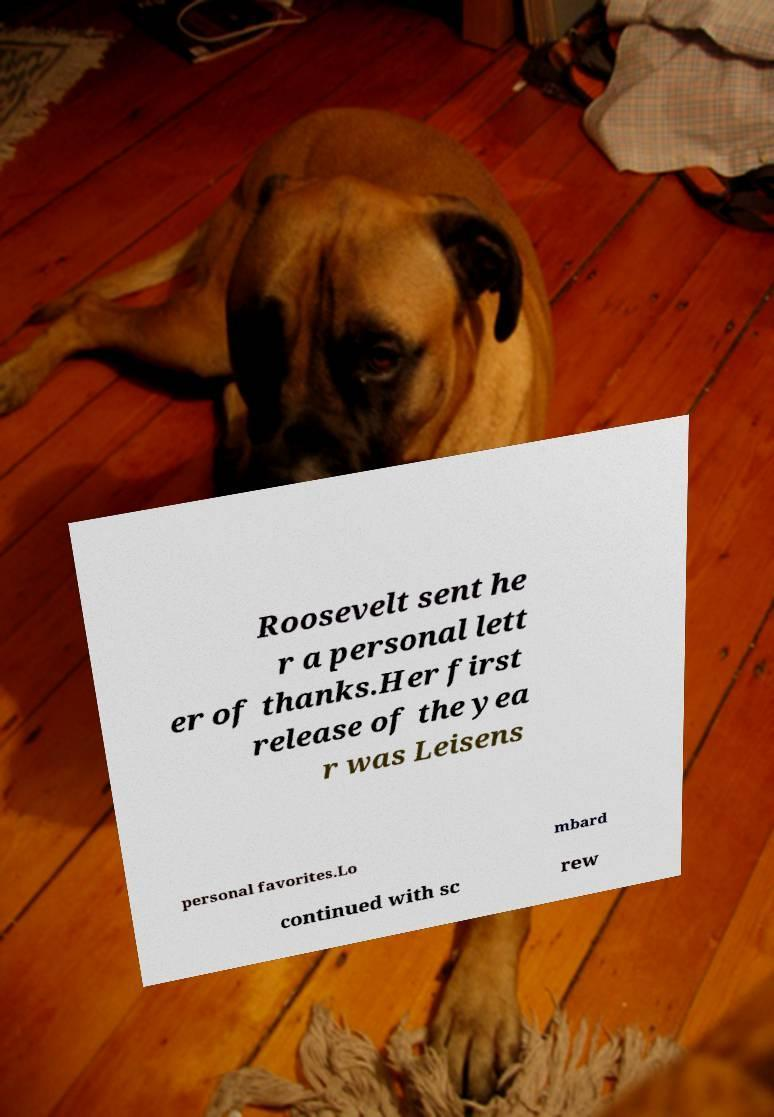Can you accurately transcribe the text from the provided image for me? Roosevelt sent he r a personal lett er of thanks.Her first release of the yea r was Leisens personal favorites.Lo mbard continued with sc rew 